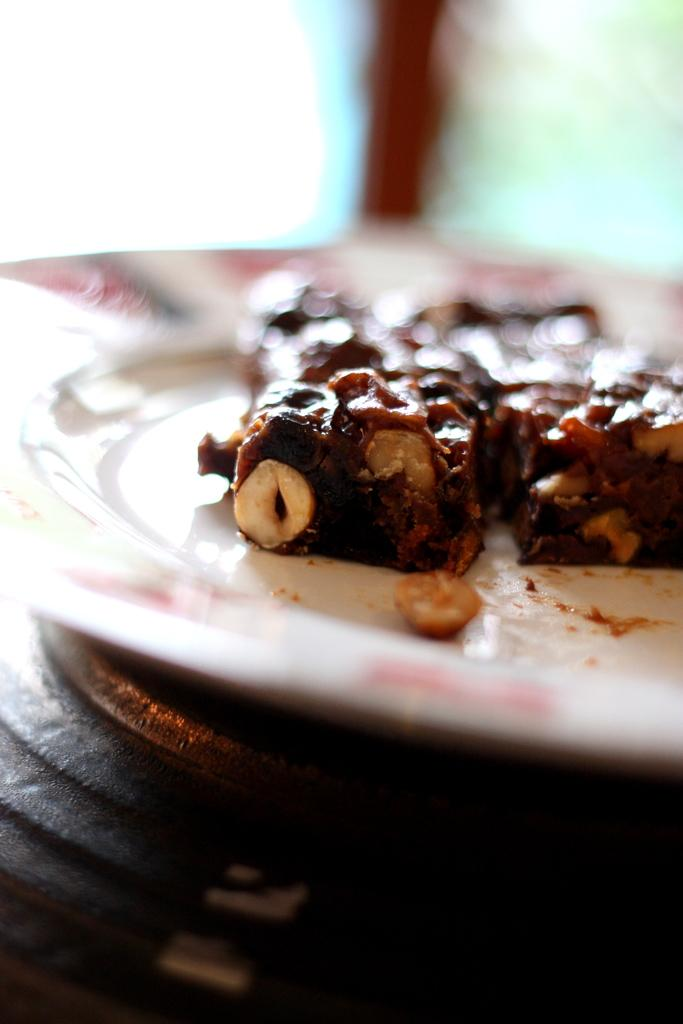What is on the plate in the image? There are food items on a plate in the image. What color is the plate? The plate is white in color. What is the plate resting on? The plate is on an object in the image. What can be seen in the background of the image? There are other objects in the background of the image. Are there any creatures interacting with the food items on the plate in the image? There are no creatures present in the image; it only features a plate with food items and other objects in the background. Can you see any fairies flying around the plate in the image? There are no fairies present in the image; it only features a plate with food items and other objects in the background. 